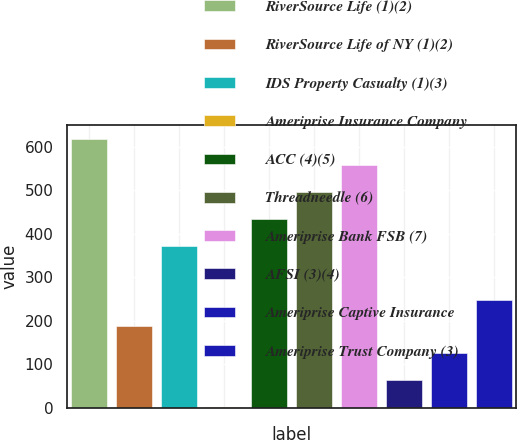Convert chart to OTSL. <chart><loc_0><loc_0><loc_500><loc_500><bar_chart><fcel>RiverSource Life (1)(2)<fcel>RiverSource Life of NY (1)(2)<fcel>IDS Property Casualty (1)(3)<fcel>Ameriprise Insurance Company<fcel>ACC (4)(5)<fcel>Threadneedle (6)<fcel>Ameriprise Bank FSB (7)<fcel>AFSI (3)(4)<fcel>Ameriprise Captive Insurance<fcel>Ameriprise Trust Company (3)<nl><fcel>619<fcel>187.1<fcel>372.2<fcel>2<fcel>433.9<fcel>495.6<fcel>557.3<fcel>63.7<fcel>125.4<fcel>248.8<nl></chart> 